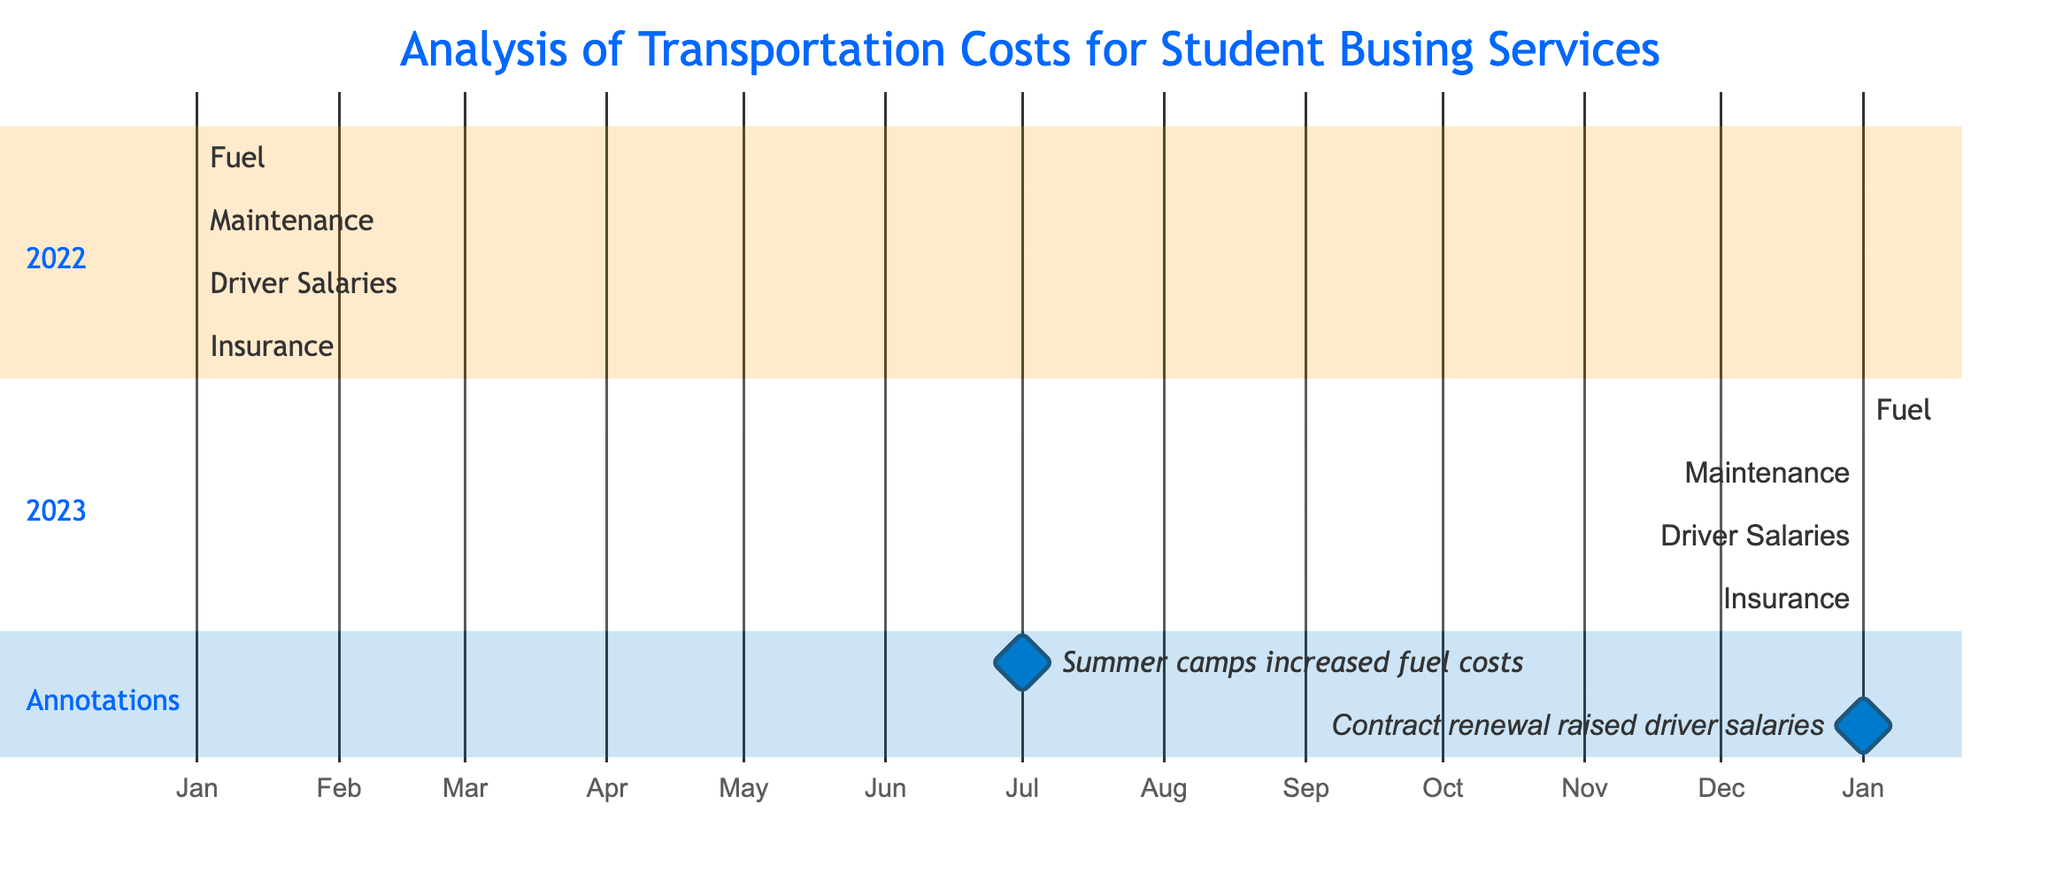What are the total months represented in the diagram? The diagram shows the breakdown of costs for two years: 2022 and 2023. Each year covers a duration of 12 months. Therefore, the total months are 12 (for 2022) + 12 (for 2023) = 24 months.
Answer: 24 Which month had increased fuel costs due to summer camps? The annotation in the diagram indicates that summer camps increased fuel costs in July 2022. It specifically highlights this month, allowing us to directly refer to it as the answer.
Answer: July 2022 What event raised driver salaries? The diagram contains an annotation indicating that "Contract renewal raised driver salaries." This explanation allows for a direct correspondence to the reason for salary increases without additional data interpretation.
Answer: Contract renewal How many categories of costs are represented in 2022? The diagram shows four categories for 2022: Fuel, Maintenance, Driver Salaries, and Insurance. By counting these categories, we find a total of four distinct cost types listed for that year.
Answer: 4 Which year shows a consistent expense across its cost categories? Both years in the diagram show that all categories (Fuel, Maintenance, Driver Salaries, Insurance) have expenses listed for every month. Hence, we can conclude that the expenses are consistent across both displayed years. Additionally, this is deduced from the layout where each category persists throughout the entire year.
Answer: Both years In which month did new driver salary costs start to be incurred? The annotation indicates that driver salaries were raised starting in January 2023 due to a contract renewal. Therefore, this month marks the beginning of mortgage costs linked to driver salaries in the timeline.
Answer: January 2023 What was the starting month for the fuel expenses in 2023? The diagram clearly shows that fuel expenses for 2023 began in January. By observing the timeline representation for fuel, we can identify that it stretches from January 2023 for a total of 12 months.
Answer: January How many total cost categories are tracked in the diagram overall? The diagram reflects that there are four distinct cost categories (Fuel, Maintenance, Driver Salaries, Insurance) tracked for both 2022 and 2023. Thus, the overall total remains the same across both years, counting as four.
Answer: 4 What type of diagram is being used to represent the data? The diagram is identified as a Gantt chart, which is a visual representation for project timelines, including various resources and expenses as stacked over time. It specifically shows the duration of costs per category visually over the specified periods.
Answer: Gantt chart 